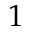<formula> <loc_0><loc_0><loc_500><loc_500>1</formula> 